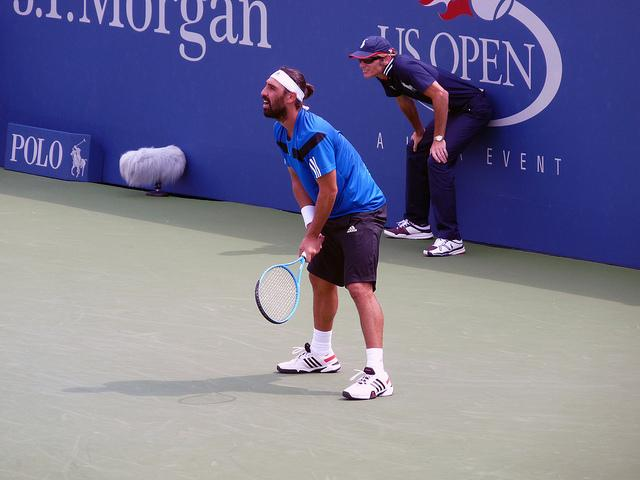What do the sunglasses worn here serve as? Please explain your reasoning. glare protection. Whether at a tennis match or driving, sunglasses are used to prevent glare from the sun. 